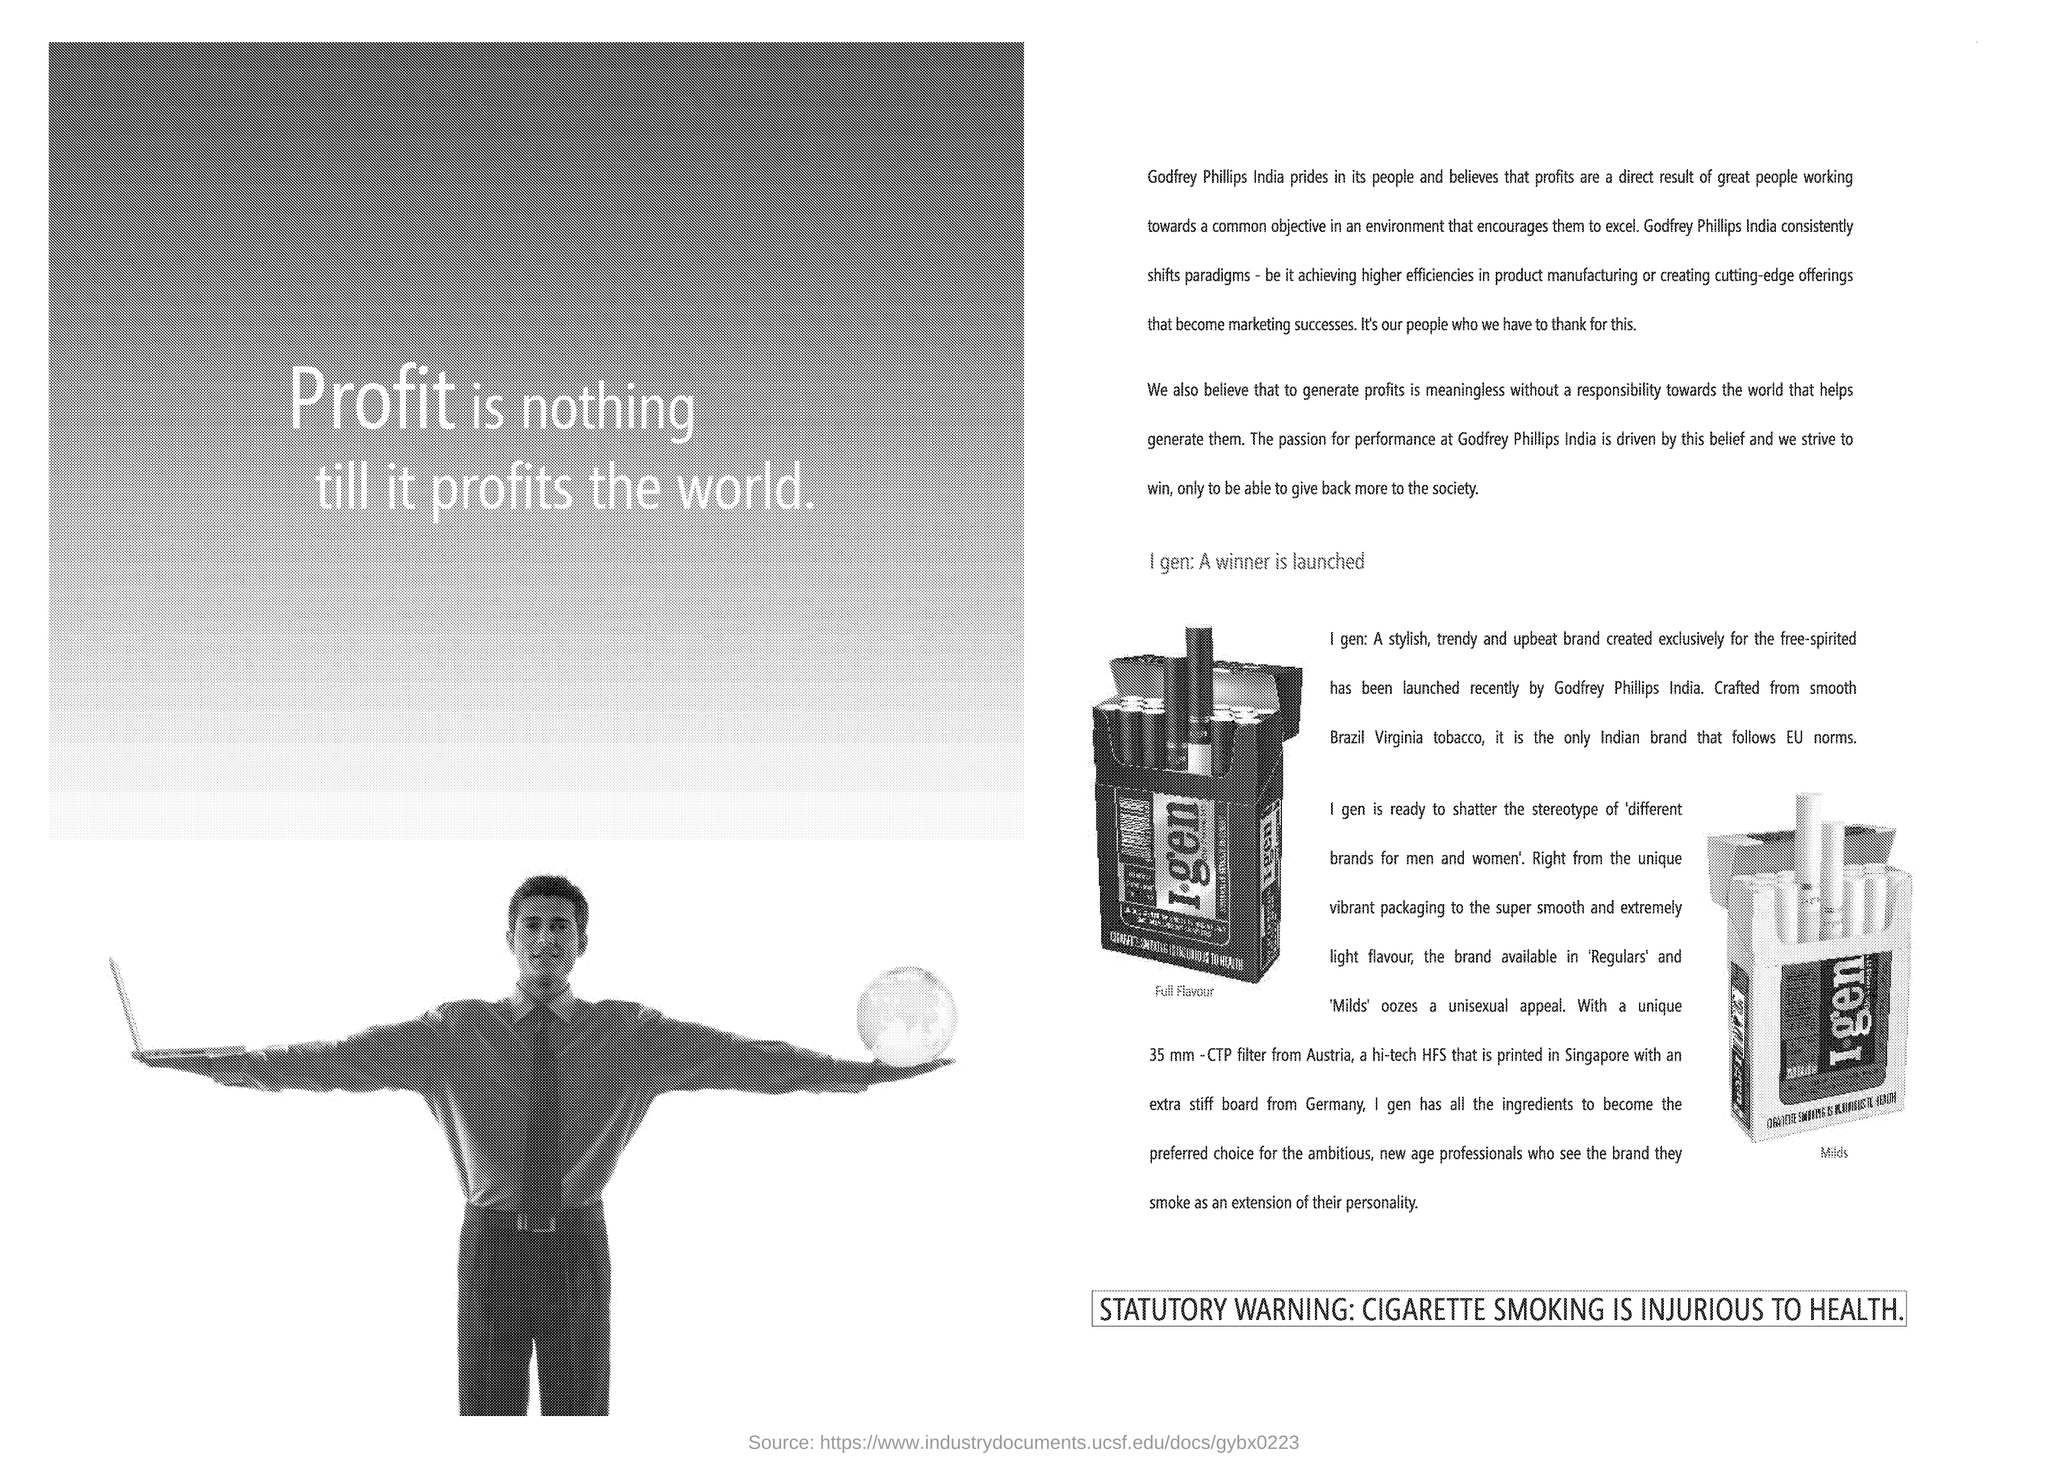Identify some key points in this picture. Cigarette smoking is detrimental to health, as evidenced by the statutory warning "CIGARETTE SMOKING IS INJURIOUS TO HEALTH. 